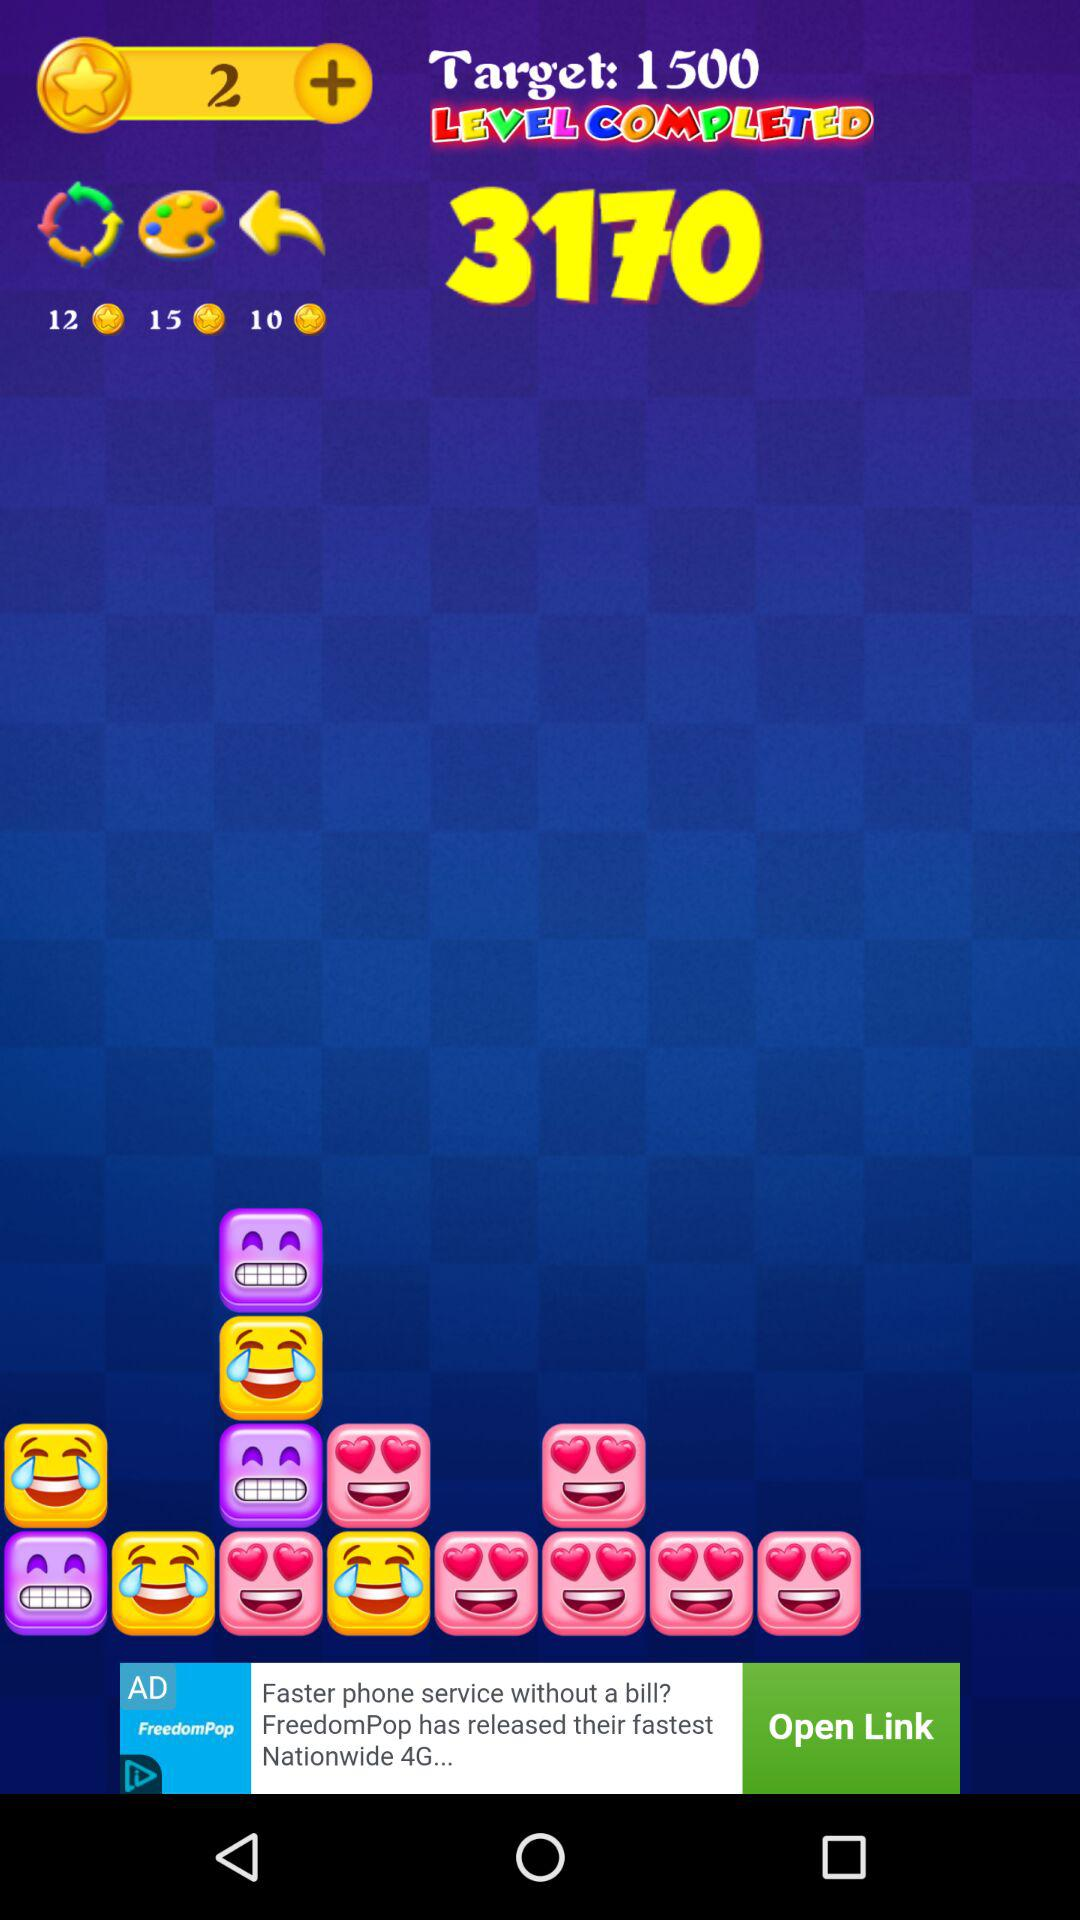What are the number of star points?
When the provided information is insufficient, respond with <no answer>. <no answer> 